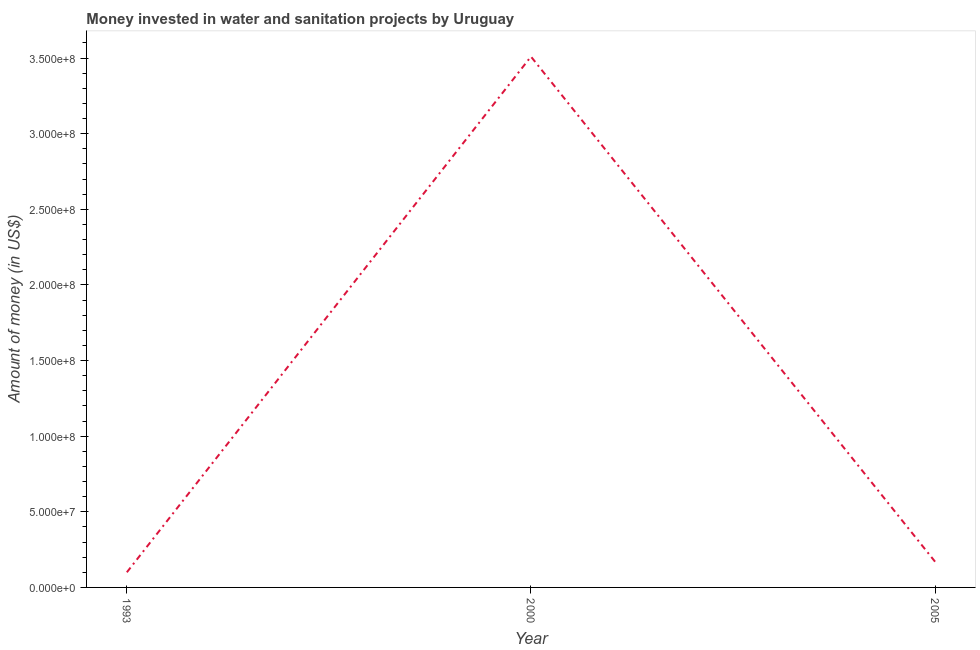What is the investment in 1993?
Offer a terse response. 1.00e+07. Across all years, what is the maximum investment?
Give a very brief answer. 3.51e+08. Across all years, what is the minimum investment?
Offer a very short reply. 1.00e+07. In which year was the investment maximum?
Your answer should be compact. 2000. What is the sum of the investment?
Make the answer very short. 3.78e+08. What is the difference between the investment in 1993 and 2005?
Keep it short and to the point. -7.00e+06. What is the average investment per year?
Your answer should be compact. 1.26e+08. What is the median investment?
Keep it short and to the point. 1.70e+07. In how many years, is the investment greater than 150000000 US$?
Ensure brevity in your answer.  1. What is the ratio of the investment in 1993 to that in 2000?
Keep it short and to the point. 0.03. What is the difference between the highest and the second highest investment?
Your response must be concise. 3.34e+08. What is the difference between the highest and the lowest investment?
Offer a terse response. 3.41e+08. In how many years, is the investment greater than the average investment taken over all years?
Offer a terse response. 1. How many years are there in the graph?
Your answer should be compact. 3. What is the difference between two consecutive major ticks on the Y-axis?
Give a very brief answer. 5.00e+07. Are the values on the major ticks of Y-axis written in scientific E-notation?
Give a very brief answer. Yes. Does the graph contain any zero values?
Your response must be concise. No. Does the graph contain grids?
Your response must be concise. No. What is the title of the graph?
Provide a succinct answer. Money invested in water and sanitation projects by Uruguay. What is the label or title of the X-axis?
Provide a short and direct response. Year. What is the label or title of the Y-axis?
Offer a terse response. Amount of money (in US$). What is the Amount of money (in US$) in 2000?
Your response must be concise. 3.51e+08. What is the Amount of money (in US$) in 2005?
Keep it short and to the point. 1.70e+07. What is the difference between the Amount of money (in US$) in 1993 and 2000?
Provide a succinct answer. -3.41e+08. What is the difference between the Amount of money (in US$) in 1993 and 2005?
Make the answer very short. -7.00e+06. What is the difference between the Amount of money (in US$) in 2000 and 2005?
Provide a short and direct response. 3.34e+08. What is the ratio of the Amount of money (in US$) in 1993 to that in 2000?
Give a very brief answer. 0.03. What is the ratio of the Amount of money (in US$) in 1993 to that in 2005?
Give a very brief answer. 0.59. What is the ratio of the Amount of money (in US$) in 2000 to that in 2005?
Ensure brevity in your answer.  20.65. 